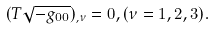<formula> <loc_0><loc_0><loc_500><loc_500>( T \sqrt { - g _ { 0 0 } } ) _ { , \nu } = 0 , ( \nu = 1 , 2 , 3 ) .</formula> 